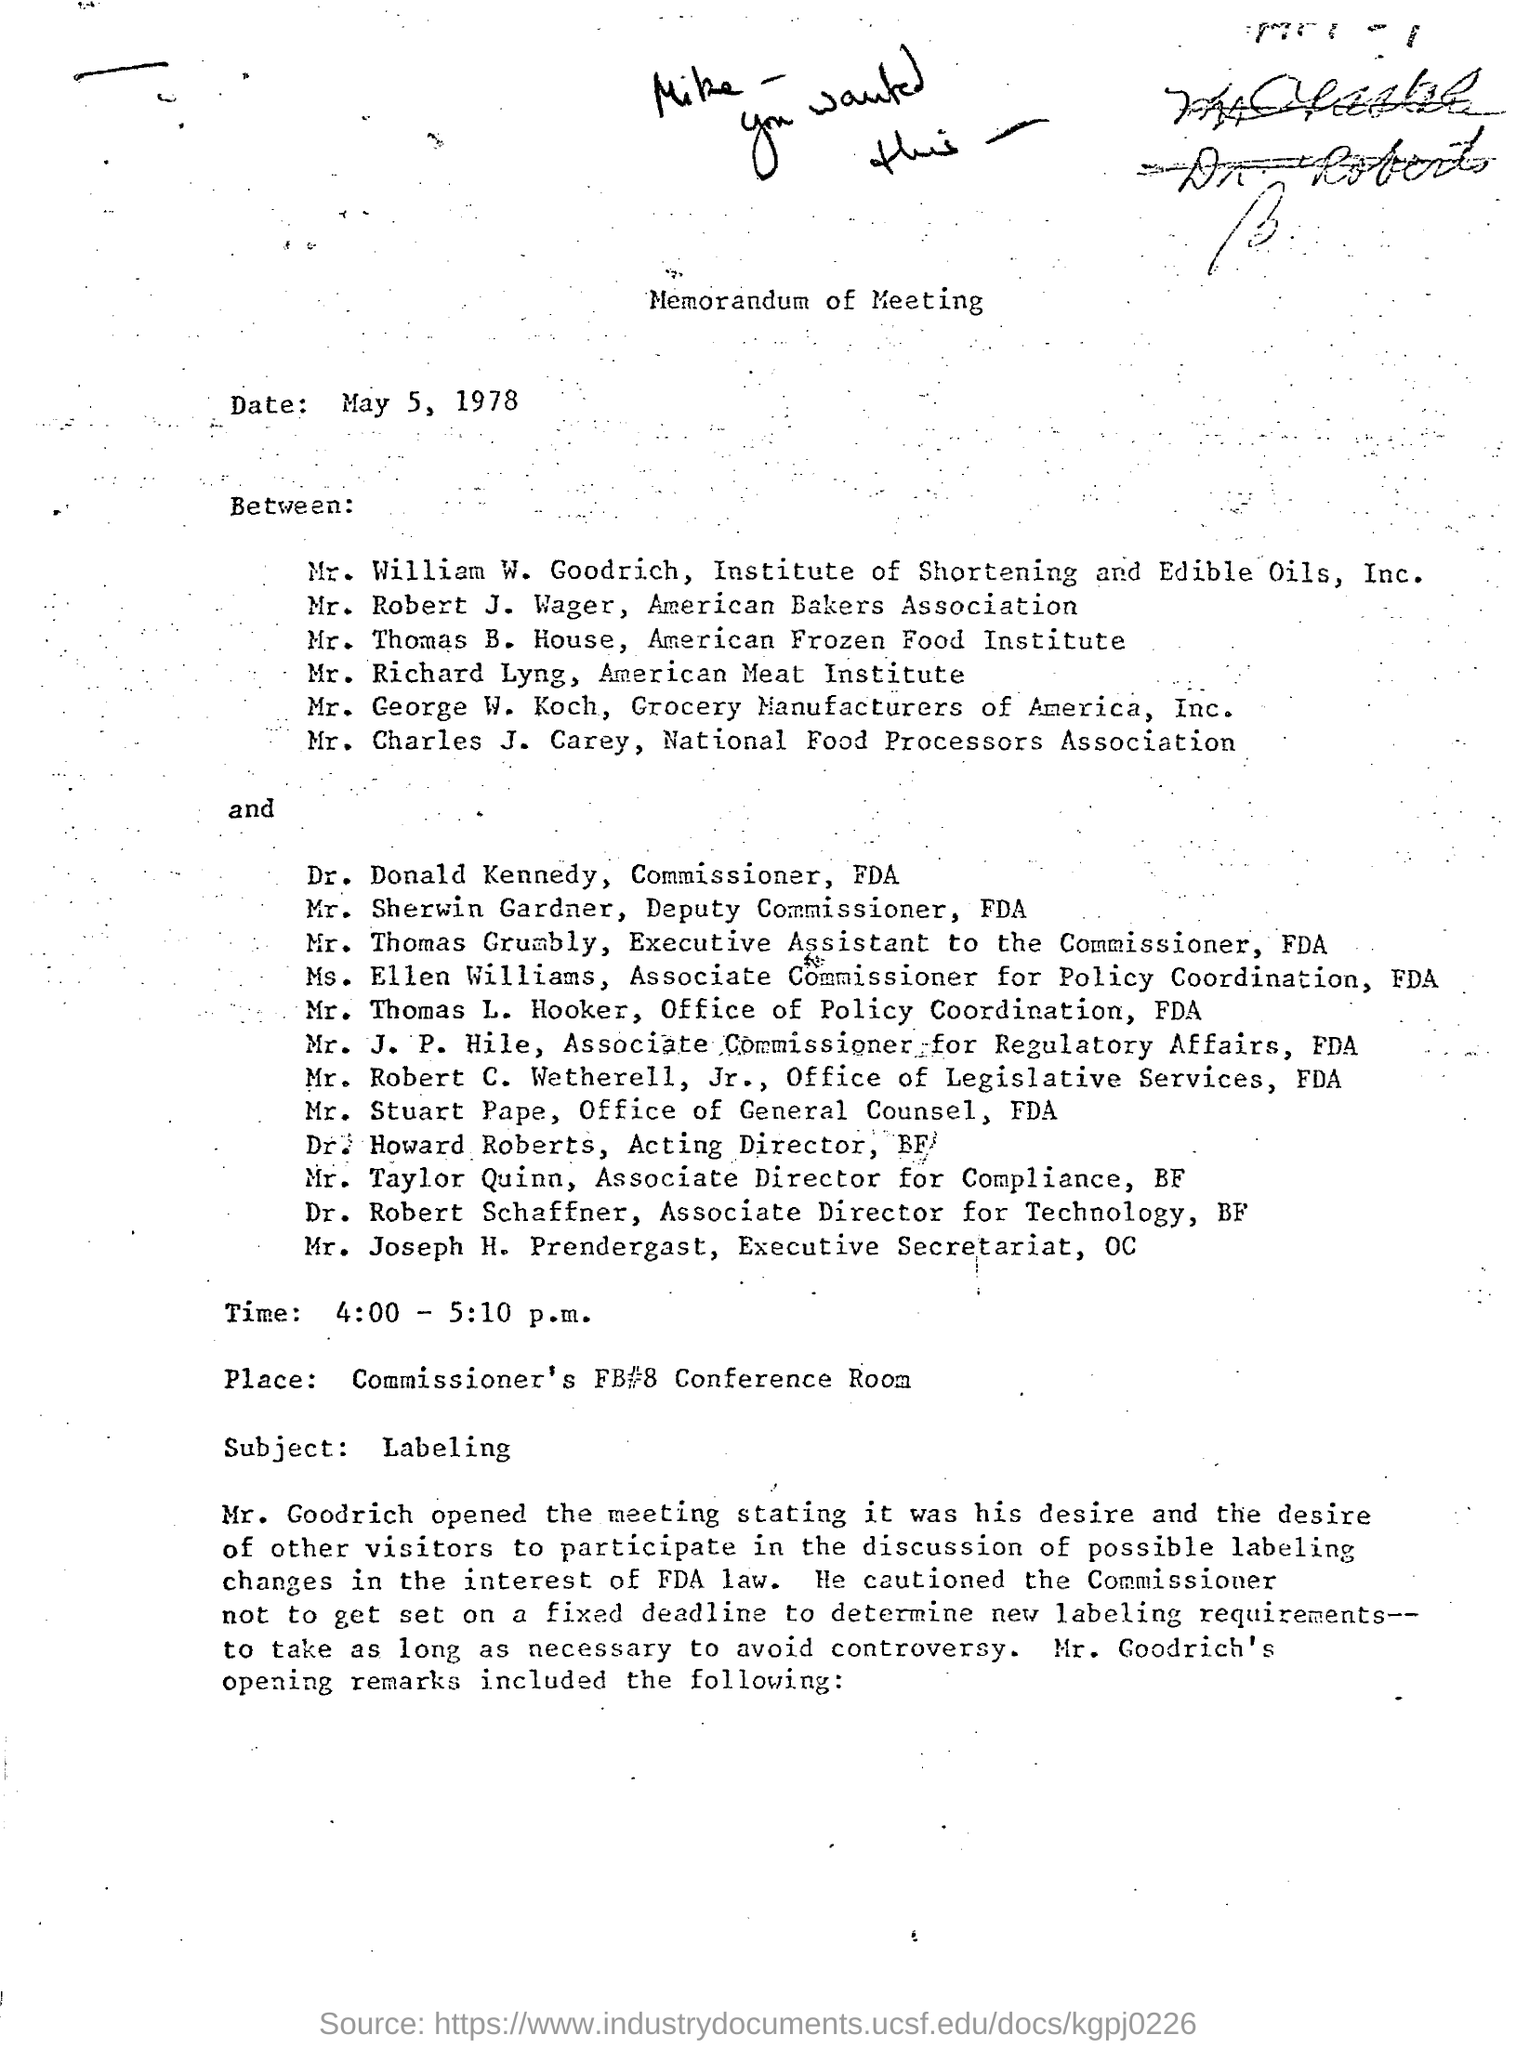Point out several critical features in this image. The Memorandum of Meeting is the heading of the document. The place mentioned in the document is the commissioner's FB#8 conference Room. The subject of the document is labeled as 'Labeling.' 